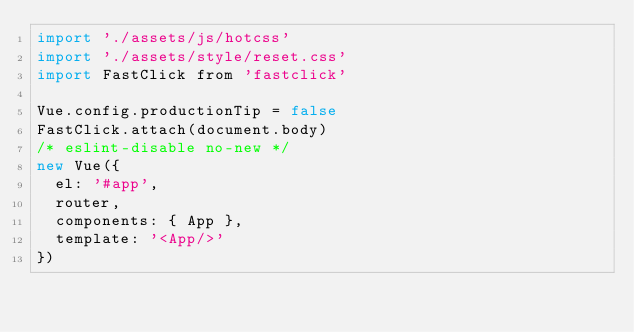<code> <loc_0><loc_0><loc_500><loc_500><_JavaScript_>import './assets/js/hotcss'
import './assets/style/reset.css'
import FastClick from 'fastclick'

Vue.config.productionTip = false
FastClick.attach(document.body)
/* eslint-disable no-new */
new Vue({
  el: '#app',
  router,
  components: { App },
  template: '<App/>'
})
</code> 